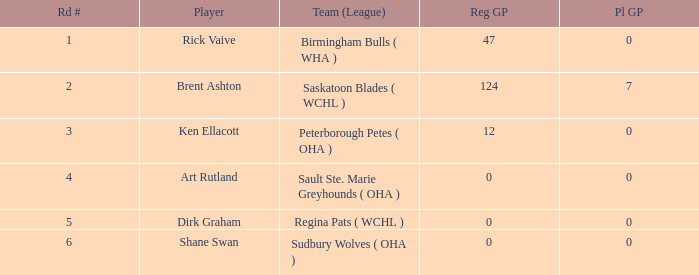Give me the full table as a dictionary. {'header': ['Rd #', 'Player', 'Team (League)', 'Reg GP', 'Pl GP'], 'rows': [['1', 'Rick Vaive', 'Birmingham Bulls ( WHA )', '47', '0'], ['2', 'Brent Ashton', 'Saskatoon Blades ( WCHL )', '124', '7'], ['3', 'Ken Ellacott', 'Peterborough Petes ( OHA )', '12', '0'], ['4', 'Art Rutland', 'Sault Ste. Marie Greyhounds ( OHA )', '0', '0'], ['5', 'Dirk Graham', 'Regina Pats ( WCHL )', '0', '0'], ['6', 'Shane Swan', 'Sudbury Wolves ( OHA )', '0', '0']]} How many reg GP for rick vaive in round 1? None. 